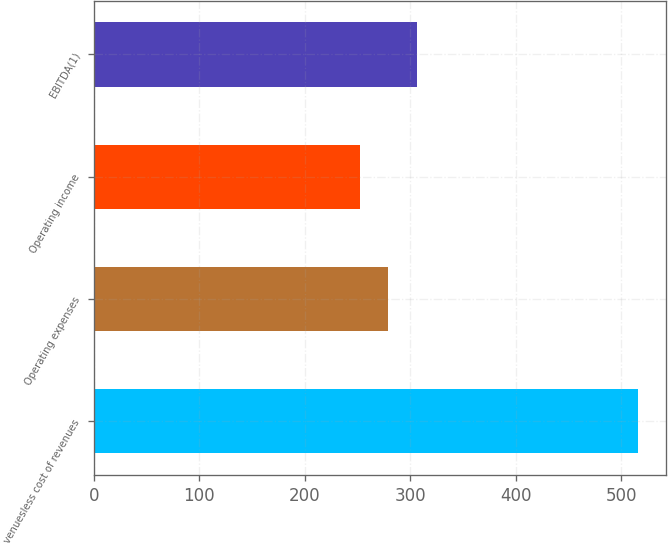Convert chart. <chart><loc_0><loc_0><loc_500><loc_500><bar_chart><fcel>Revenuesless cost of revenues<fcel>Operating expenses<fcel>Operating income<fcel>EBITDA(1)<nl><fcel>516.3<fcel>278.61<fcel>252.2<fcel>306.6<nl></chart> 